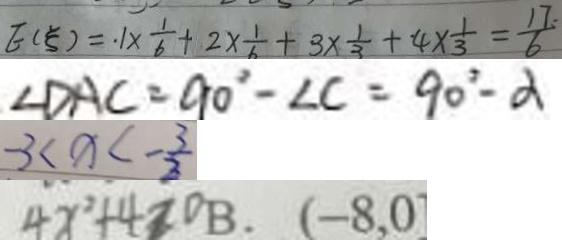<formula> <loc_0><loc_0><loc_500><loc_500>E ( \varepsilon ) = . 1 \times \frac { 1 } { 6 } + 2 \times \frac { 1 } { 6 } + 3 \times \frac { 1 } { 3 } + 4 \times \frac { 1 } { 3 } = \frac { 1 7 } { 6 } 
 \angle D A C = 9 0 ^ { \circ } - \angle C = 9 0 ^ { \circ } - \alpha 
 - 3 < x < - \frac { 3 } { 2 } 
 4 x ^ { 2 } + 4 > 0 B . ( - 8 , 0</formula> 